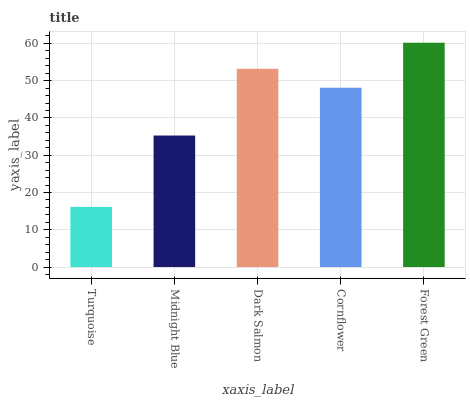Is Turquoise the minimum?
Answer yes or no. Yes. Is Forest Green the maximum?
Answer yes or no. Yes. Is Midnight Blue the minimum?
Answer yes or no. No. Is Midnight Blue the maximum?
Answer yes or no. No. Is Midnight Blue greater than Turquoise?
Answer yes or no. Yes. Is Turquoise less than Midnight Blue?
Answer yes or no. Yes. Is Turquoise greater than Midnight Blue?
Answer yes or no. No. Is Midnight Blue less than Turquoise?
Answer yes or no. No. Is Cornflower the high median?
Answer yes or no. Yes. Is Cornflower the low median?
Answer yes or no. Yes. Is Turquoise the high median?
Answer yes or no. No. Is Midnight Blue the low median?
Answer yes or no. No. 